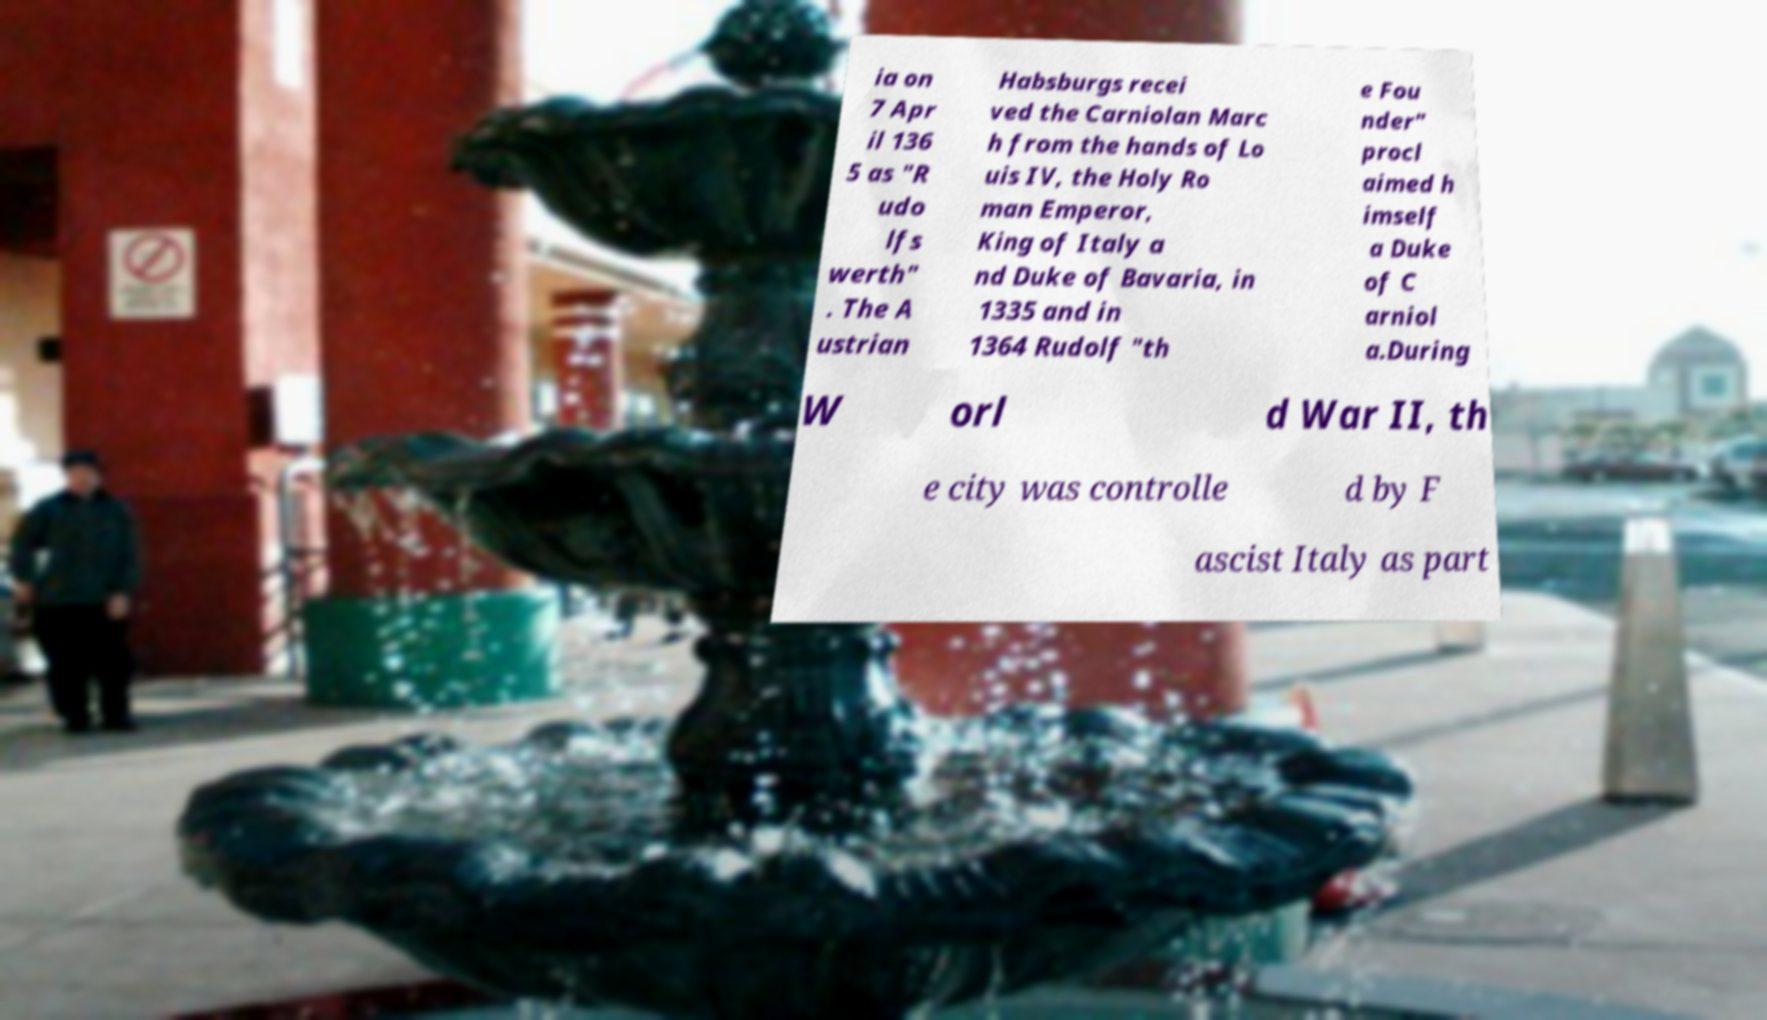Can you read and provide the text displayed in the image?This photo seems to have some interesting text. Can you extract and type it out for me? ia on 7 Apr il 136 5 as "R udo lfs werth" . The A ustrian Habsburgs recei ved the Carniolan Marc h from the hands of Lo uis IV, the Holy Ro man Emperor, King of Italy a nd Duke of Bavaria, in 1335 and in 1364 Rudolf "th e Fou nder" procl aimed h imself a Duke of C arniol a.During W orl d War II, th e city was controlle d by F ascist Italy as part 